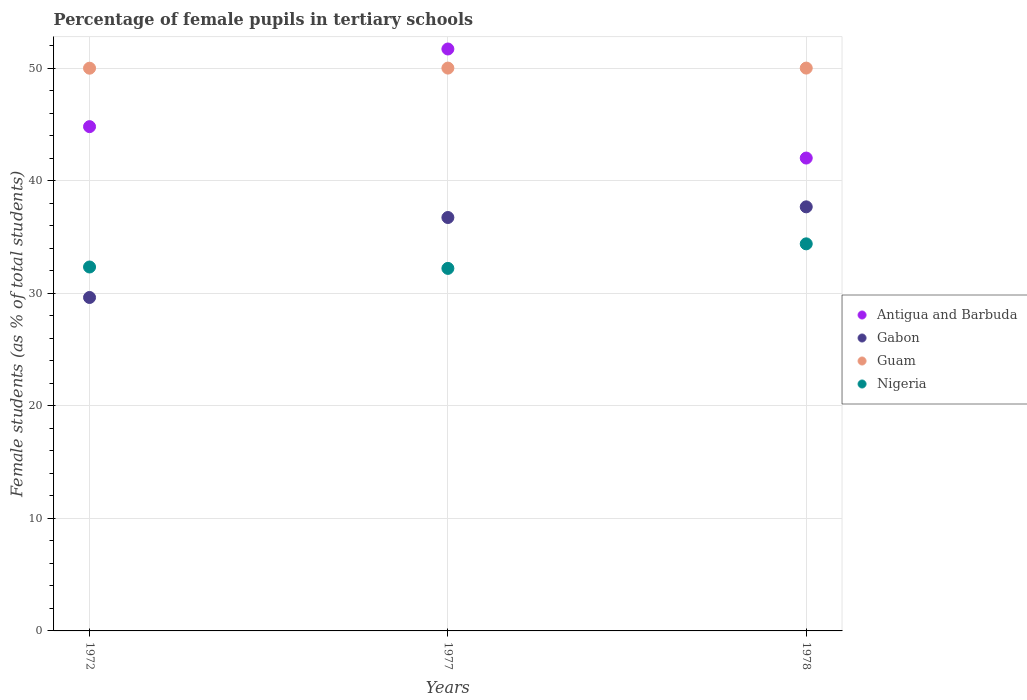How many different coloured dotlines are there?
Provide a short and direct response. 4. Is the number of dotlines equal to the number of legend labels?
Offer a very short reply. Yes. What is the percentage of female pupils in tertiary schools in Guam in 1977?
Provide a short and direct response. 50. Across all years, what is the minimum percentage of female pupils in tertiary schools in Guam?
Your response must be concise. 49.99. In which year was the percentage of female pupils in tertiary schools in Nigeria maximum?
Give a very brief answer. 1978. What is the total percentage of female pupils in tertiary schools in Gabon in the graph?
Provide a succinct answer. 104.02. What is the difference between the percentage of female pupils in tertiary schools in Antigua and Barbuda in 1972 and that in 1977?
Make the answer very short. -6.9. What is the difference between the percentage of female pupils in tertiary schools in Gabon in 1978 and the percentage of female pupils in tertiary schools in Antigua and Barbuda in 1977?
Give a very brief answer. -14.02. What is the average percentage of female pupils in tertiary schools in Guam per year?
Provide a short and direct response. 50. In the year 1972, what is the difference between the percentage of female pupils in tertiary schools in Guam and percentage of female pupils in tertiary schools in Antigua and Barbuda?
Make the answer very short. 5.19. What is the ratio of the percentage of female pupils in tertiary schools in Antigua and Barbuda in 1972 to that in 1978?
Your answer should be very brief. 1.07. What is the difference between the highest and the second highest percentage of female pupils in tertiary schools in Nigeria?
Give a very brief answer. 2.06. What is the difference between the highest and the lowest percentage of female pupils in tertiary schools in Gabon?
Give a very brief answer. 8.05. Is the sum of the percentage of female pupils in tertiary schools in Antigua and Barbuda in 1972 and 1977 greater than the maximum percentage of female pupils in tertiary schools in Nigeria across all years?
Offer a terse response. Yes. Is it the case that in every year, the sum of the percentage of female pupils in tertiary schools in Antigua and Barbuda and percentage of female pupils in tertiary schools in Guam  is greater than the sum of percentage of female pupils in tertiary schools in Gabon and percentage of female pupils in tertiary schools in Nigeria?
Keep it short and to the point. Yes. Does the percentage of female pupils in tertiary schools in Guam monotonically increase over the years?
Ensure brevity in your answer.  No. Is the percentage of female pupils in tertiary schools in Nigeria strictly greater than the percentage of female pupils in tertiary schools in Antigua and Barbuda over the years?
Your response must be concise. No. Is the percentage of female pupils in tertiary schools in Guam strictly less than the percentage of female pupils in tertiary schools in Nigeria over the years?
Make the answer very short. No. How many years are there in the graph?
Your answer should be very brief. 3. Does the graph contain grids?
Offer a very short reply. Yes. Where does the legend appear in the graph?
Your response must be concise. Center right. How are the legend labels stacked?
Your answer should be very brief. Vertical. What is the title of the graph?
Provide a short and direct response. Percentage of female pupils in tertiary schools. What is the label or title of the X-axis?
Your answer should be compact. Years. What is the label or title of the Y-axis?
Provide a succinct answer. Female students (as % of total students). What is the Female students (as % of total students) of Antigua and Barbuda in 1972?
Your answer should be compact. 44.8. What is the Female students (as % of total students) of Gabon in 1972?
Ensure brevity in your answer.  29.62. What is the Female students (as % of total students) in Guam in 1972?
Keep it short and to the point. 49.99. What is the Female students (as % of total students) of Nigeria in 1972?
Your answer should be compact. 32.33. What is the Female students (as % of total students) of Antigua and Barbuda in 1977?
Offer a terse response. 51.7. What is the Female students (as % of total students) in Gabon in 1977?
Offer a terse response. 36.73. What is the Female students (as % of total students) in Guam in 1977?
Provide a succinct answer. 50. What is the Female students (as % of total students) in Nigeria in 1977?
Your response must be concise. 32.21. What is the Female students (as % of total students) of Antigua and Barbuda in 1978?
Your answer should be very brief. 42.01. What is the Female students (as % of total students) in Gabon in 1978?
Your answer should be very brief. 37.67. What is the Female students (as % of total students) of Guam in 1978?
Offer a terse response. 50. What is the Female students (as % of total students) of Nigeria in 1978?
Ensure brevity in your answer.  34.39. Across all years, what is the maximum Female students (as % of total students) of Antigua and Barbuda?
Provide a short and direct response. 51.7. Across all years, what is the maximum Female students (as % of total students) of Gabon?
Offer a terse response. 37.67. Across all years, what is the maximum Female students (as % of total students) of Guam?
Offer a very short reply. 50. Across all years, what is the maximum Female students (as % of total students) in Nigeria?
Provide a short and direct response. 34.39. Across all years, what is the minimum Female students (as % of total students) in Antigua and Barbuda?
Your response must be concise. 42.01. Across all years, what is the minimum Female students (as % of total students) in Gabon?
Provide a short and direct response. 29.62. Across all years, what is the minimum Female students (as % of total students) of Guam?
Your answer should be very brief. 49.99. Across all years, what is the minimum Female students (as % of total students) in Nigeria?
Provide a succinct answer. 32.21. What is the total Female students (as % of total students) of Antigua and Barbuda in the graph?
Your response must be concise. 138.5. What is the total Female students (as % of total students) of Gabon in the graph?
Ensure brevity in your answer.  104.02. What is the total Female students (as % of total students) of Guam in the graph?
Give a very brief answer. 149.99. What is the total Female students (as % of total students) in Nigeria in the graph?
Your answer should be compact. 98.92. What is the difference between the Female students (as % of total students) of Antigua and Barbuda in 1972 and that in 1977?
Ensure brevity in your answer.  -6.9. What is the difference between the Female students (as % of total students) of Gabon in 1972 and that in 1977?
Make the answer very short. -7.1. What is the difference between the Female students (as % of total students) of Guam in 1972 and that in 1977?
Give a very brief answer. -0.01. What is the difference between the Female students (as % of total students) of Nigeria in 1972 and that in 1977?
Provide a short and direct response. 0.12. What is the difference between the Female students (as % of total students) in Antigua and Barbuda in 1972 and that in 1978?
Offer a very short reply. 2.79. What is the difference between the Female students (as % of total students) in Gabon in 1972 and that in 1978?
Keep it short and to the point. -8.05. What is the difference between the Female students (as % of total students) of Guam in 1972 and that in 1978?
Offer a terse response. -0.01. What is the difference between the Female students (as % of total students) in Nigeria in 1972 and that in 1978?
Make the answer very short. -2.06. What is the difference between the Female students (as % of total students) of Antigua and Barbuda in 1977 and that in 1978?
Your response must be concise. 9.69. What is the difference between the Female students (as % of total students) of Gabon in 1977 and that in 1978?
Provide a succinct answer. -0.95. What is the difference between the Female students (as % of total students) of Guam in 1977 and that in 1978?
Your response must be concise. 0. What is the difference between the Female students (as % of total students) of Nigeria in 1977 and that in 1978?
Make the answer very short. -2.18. What is the difference between the Female students (as % of total students) in Antigua and Barbuda in 1972 and the Female students (as % of total students) in Gabon in 1977?
Offer a very short reply. 8.07. What is the difference between the Female students (as % of total students) of Antigua and Barbuda in 1972 and the Female students (as % of total students) of Guam in 1977?
Your answer should be compact. -5.2. What is the difference between the Female students (as % of total students) in Antigua and Barbuda in 1972 and the Female students (as % of total students) in Nigeria in 1977?
Provide a succinct answer. 12.59. What is the difference between the Female students (as % of total students) of Gabon in 1972 and the Female students (as % of total students) of Guam in 1977?
Make the answer very short. -20.38. What is the difference between the Female students (as % of total students) in Gabon in 1972 and the Female students (as % of total students) in Nigeria in 1977?
Your answer should be very brief. -2.58. What is the difference between the Female students (as % of total students) of Guam in 1972 and the Female students (as % of total students) of Nigeria in 1977?
Provide a succinct answer. 17.78. What is the difference between the Female students (as % of total students) in Antigua and Barbuda in 1972 and the Female students (as % of total students) in Gabon in 1978?
Give a very brief answer. 7.12. What is the difference between the Female students (as % of total students) in Antigua and Barbuda in 1972 and the Female students (as % of total students) in Guam in 1978?
Your response must be concise. -5.2. What is the difference between the Female students (as % of total students) of Antigua and Barbuda in 1972 and the Female students (as % of total students) of Nigeria in 1978?
Keep it short and to the point. 10.41. What is the difference between the Female students (as % of total students) of Gabon in 1972 and the Female students (as % of total students) of Guam in 1978?
Provide a short and direct response. -20.38. What is the difference between the Female students (as % of total students) in Gabon in 1972 and the Female students (as % of total students) in Nigeria in 1978?
Provide a short and direct response. -4.76. What is the difference between the Female students (as % of total students) of Guam in 1972 and the Female students (as % of total students) of Nigeria in 1978?
Your response must be concise. 15.6. What is the difference between the Female students (as % of total students) of Antigua and Barbuda in 1977 and the Female students (as % of total students) of Gabon in 1978?
Provide a short and direct response. 14.02. What is the difference between the Female students (as % of total students) of Antigua and Barbuda in 1977 and the Female students (as % of total students) of Guam in 1978?
Your answer should be very brief. 1.7. What is the difference between the Female students (as % of total students) of Antigua and Barbuda in 1977 and the Female students (as % of total students) of Nigeria in 1978?
Your answer should be very brief. 17.31. What is the difference between the Female students (as % of total students) in Gabon in 1977 and the Female students (as % of total students) in Guam in 1978?
Provide a succinct answer. -13.27. What is the difference between the Female students (as % of total students) of Gabon in 1977 and the Female students (as % of total students) of Nigeria in 1978?
Provide a succinct answer. 2.34. What is the difference between the Female students (as % of total students) of Guam in 1977 and the Female students (as % of total students) of Nigeria in 1978?
Your answer should be compact. 15.61. What is the average Female students (as % of total students) of Antigua and Barbuda per year?
Keep it short and to the point. 46.17. What is the average Female students (as % of total students) in Gabon per year?
Provide a succinct answer. 34.67. What is the average Female students (as % of total students) in Guam per year?
Ensure brevity in your answer.  50. What is the average Female students (as % of total students) of Nigeria per year?
Keep it short and to the point. 32.97. In the year 1972, what is the difference between the Female students (as % of total students) of Antigua and Barbuda and Female students (as % of total students) of Gabon?
Provide a succinct answer. 15.18. In the year 1972, what is the difference between the Female students (as % of total students) of Antigua and Barbuda and Female students (as % of total students) of Guam?
Provide a short and direct response. -5.19. In the year 1972, what is the difference between the Female students (as % of total students) in Antigua and Barbuda and Female students (as % of total students) in Nigeria?
Provide a succinct answer. 12.47. In the year 1972, what is the difference between the Female students (as % of total students) in Gabon and Female students (as % of total students) in Guam?
Keep it short and to the point. -20.37. In the year 1972, what is the difference between the Female students (as % of total students) of Gabon and Female students (as % of total students) of Nigeria?
Provide a succinct answer. -2.71. In the year 1972, what is the difference between the Female students (as % of total students) in Guam and Female students (as % of total students) in Nigeria?
Provide a succinct answer. 17.66. In the year 1977, what is the difference between the Female students (as % of total students) in Antigua and Barbuda and Female students (as % of total students) in Gabon?
Offer a very short reply. 14.97. In the year 1977, what is the difference between the Female students (as % of total students) of Antigua and Barbuda and Female students (as % of total students) of Guam?
Your answer should be compact. 1.7. In the year 1977, what is the difference between the Female students (as % of total students) of Antigua and Barbuda and Female students (as % of total students) of Nigeria?
Your response must be concise. 19.49. In the year 1977, what is the difference between the Female students (as % of total students) in Gabon and Female students (as % of total students) in Guam?
Your response must be concise. -13.27. In the year 1977, what is the difference between the Female students (as % of total students) of Gabon and Female students (as % of total students) of Nigeria?
Provide a short and direct response. 4.52. In the year 1977, what is the difference between the Female students (as % of total students) in Guam and Female students (as % of total students) in Nigeria?
Provide a short and direct response. 17.79. In the year 1978, what is the difference between the Female students (as % of total students) in Antigua and Barbuda and Female students (as % of total students) in Gabon?
Make the answer very short. 4.33. In the year 1978, what is the difference between the Female students (as % of total students) in Antigua and Barbuda and Female students (as % of total students) in Guam?
Make the answer very short. -7.99. In the year 1978, what is the difference between the Female students (as % of total students) of Antigua and Barbuda and Female students (as % of total students) of Nigeria?
Provide a succinct answer. 7.62. In the year 1978, what is the difference between the Female students (as % of total students) of Gabon and Female students (as % of total students) of Guam?
Your answer should be compact. -12.33. In the year 1978, what is the difference between the Female students (as % of total students) in Gabon and Female students (as % of total students) in Nigeria?
Keep it short and to the point. 3.29. In the year 1978, what is the difference between the Female students (as % of total students) in Guam and Female students (as % of total students) in Nigeria?
Your answer should be compact. 15.61. What is the ratio of the Female students (as % of total students) in Antigua and Barbuda in 1972 to that in 1977?
Provide a short and direct response. 0.87. What is the ratio of the Female students (as % of total students) of Gabon in 1972 to that in 1977?
Your response must be concise. 0.81. What is the ratio of the Female students (as % of total students) of Guam in 1972 to that in 1977?
Offer a very short reply. 1. What is the ratio of the Female students (as % of total students) of Nigeria in 1972 to that in 1977?
Your answer should be compact. 1. What is the ratio of the Female students (as % of total students) in Antigua and Barbuda in 1972 to that in 1978?
Give a very brief answer. 1.07. What is the ratio of the Female students (as % of total students) in Gabon in 1972 to that in 1978?
Offer a terse response. 0.79. What is the ratio of the Female students (as % of total students) of Nigeria in 1972 to that in 1978?
Your response must be concise. 0.94. What is the ratio of the Female students (as % of total students) of Antigua and Barbuda in 1977 to that in 1978?
Your answer should be very brief. 1.23. What is the ratio of the Female students (as % of total students) in Gabon in 1977 to that in 1978?
Keep it short and to the point. 0.97. What is the ratio of the Female students (as % of total students) in Guam in 1977 to that in 1978?
Offer a terse response. 1. What is the ratio of the Female students (as % of total students) of Nigeria in 1977 to that in 1978?
Make the answer very short. 0.94. What is the difference between the highest and the second highest Female students (as % of total students) in Antigua and Barbuda?
Provide a short and direct response. 6.9. What is the difference between the highest and the second highest Female students (as % of total students) of Gabon?
Offer a very short reply. 0.95. What is the difference between the highest and the second highest Female students (as % of total students) of Nigeria?
Offer a very short reply. 2.06. What is the difference between the highest and the lowest Female students (as % of total students) in Antigua and Barbuda?
Offer a very short reply. 9.69. What is the difference between the highest and the lowest Female students (as % of total students) of Gabon?
Your answer should be compact. 8.05. What is the difference between the highest and the lowest Female students (as % of total students) of Guam?
Offer a very short reply. 0.01. What is the difference between the highest and the lowest Female students (as % of total students) of Nigeria?
Make the answer very short. 2.18. 